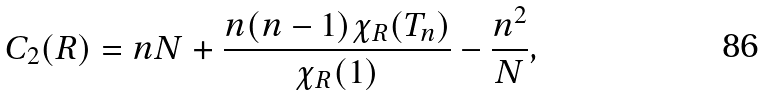<formula> <loc_0><loc_0><loc_500><loc_500>C _ { 2 } ( R ) = n N + \frac { n ( n - 1 ) \chi _ { R } ( T _ { n } ) } { \chi _ { R } ( 1 ) } - \frac { n ^ { 2 } } { N } ,</formula> 